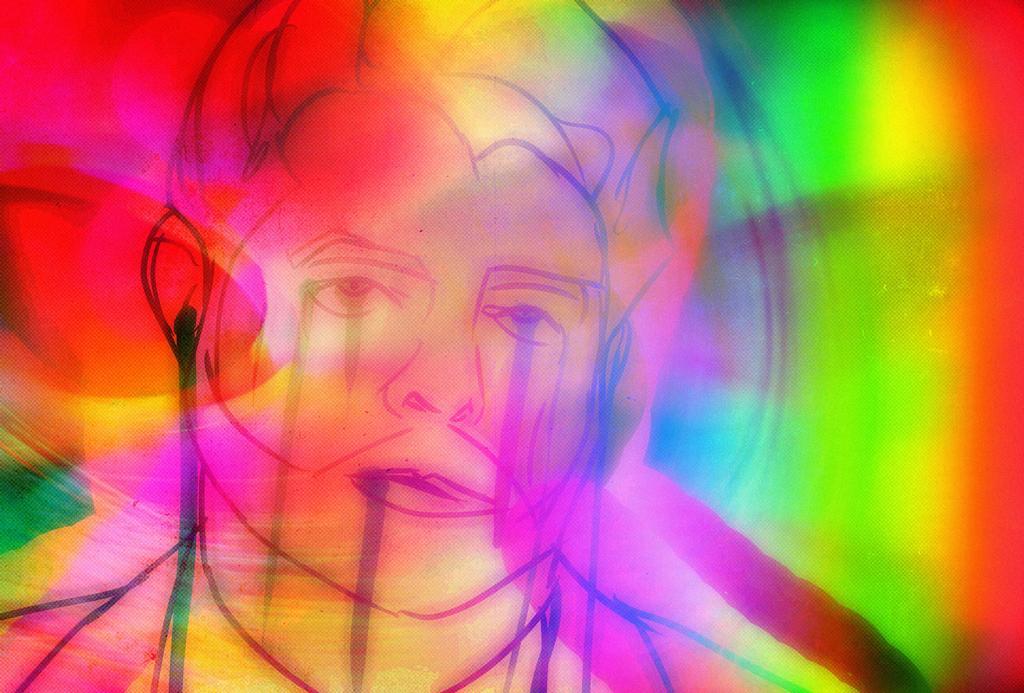Describe this image in one or two sentences. This image consists of an art. In which we can see a person. And we can also see multiple colors in this image. 